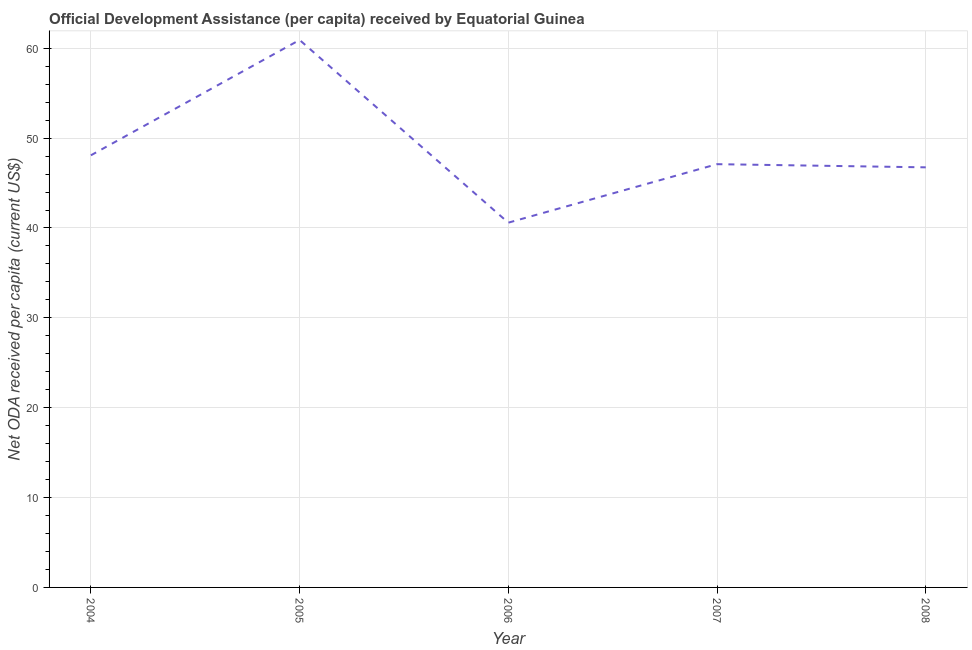What is the net oda received per capita in 2007?
Your response must be concise. 47.1. Across all years, what is the maximum net oda received per capita?
Your response must be concise. 60.92. Across all years, what is the minimum net oda received per capita?
Your answer should be very brief. 40.59. In which year was the net oda received per capita maximum?
Provide a succinct answer. 2005. What is the sum of the net oda received per capita?
Keep it short and to the point. 243.45. What is the difference between the net oda received per capita in 2005 and 2006?
Keep it short and to the point. 20.33. What is the average net oda received per capita per year?
Your response must be concise. 48.69. What is the median net oda received per capita?
Offer a terse response. 47.1. In how many years, is the net oda received per capita greater than 30 US$?
Provide a short and direct response. 5. Do a majority of the years between 2004 and 2005 (inclusive) have net oda received per capita greater than 22 US$?
Ensure brevity in your answer.  Yes. What is the ratio of the net oda received per capita in 2005 to that in 2008?
Provide a short and direct response. 1.3. Is the difference between the net oda received per capita in 2007 and 2008 greater than the difference between any two years?
Your answer should be very brief. No. What is the difference between the highest and the second highest net oda received per capita?
Offer a very short reply. 12.84. What is the difference between the highest and the lowest net oda received per capita?
Ensure brevity in your answer.  20.33. In how many years, is the net oda received per capita greater than the average net oda received per capita taken over all years?
Make the answer very short. 1. What is the difference between two consecutive major ticks on the Y-axis?
Your answer should be compact. 10. Does the graph contain any zero values?
Your answer should be very brief. No. Does the graph contain grids?
Offer a very short reply. Yes. What is the title of the graph?
Provide a succinct answer. Official Development Assistance (per capita) received by Equatorial Guinea. What is the label or title of the X-axis?
Your answer should be compact. Year. What is the label or title of the Y-axis?
Ensure brevity in your answer.  Net ODA received per capita (current US$). What is the Net ODA received per capita (current US$) in 2004?
Offer a terse response. 48.09. What is the Net ODA received per capita (current US$) of 2005?
Make the answer very short. 60.92. What is the Net ODA received per capita (current US$) of 2006?
Your answer should be very brief. 40.59. What is the Net ODA received per capita (current US$) in 2007?
Your answer should be compact. 47.1. What is the Net ODA received per capita (current US$) of 2008?
Your answer should be very brief. 46.75. What is the difference between the Net ODA received per capita (current US$) in 2004 and 2005?
Your answer should be compact. -12.84. What is the difference between the Net ODA received per capita (current US$) in 2004 and 2006?
Give a very brief answer. 7.5. What is the difference between the Net ODA received per capita (current US$) in 2004 and 2007?
Your response must be concise. 0.98. What is the difference between the Net ODA received per capita (current US$) in 2004 and 2008?
Make the answer very short. 1.34. What is the difference between the Net ODA received per capita (current US$) in 2005 and 2006?
Provide a succinct answer. 20.33. What is the difference between the Net ODA received per capita (current US$) in 2005 and 2007?
Offer a terse response. 13.82. What is the difference between the Net ODA received per capita (current US$) in 2005 and 2008?
Offer a terse response. 14.17. What is the difference between the Net ODA received per capita (current US$) in 2006 and 2007?
Keep it short and to the point. -6.51. What is the difference between the Net ODA received per capita (current US$) in 2006 and 2008?
Your answer should be compact. -6.16. What is the difference between the Net ODA received per capita (current US$) in 2007 and 2008?
Your answer should be very brief. 0.35. What is the ratio of the Net ODA received per capita (current US$) in 2004 to that in 2005?
Provide a short and direct response. 0.79. What is the ratio of the Net ODA received per capita (current US$) in 2004 to that in 2006?
Make the answer very short. 1.19. What is the ratio of the Net ODA received per capita (current US$) in 2005 to that in 2006?
Your response must be concise. 1.5. What is the ratio of the Net ODA received per capita (current US$) in 2005 to that in 2007?
Give a very brief answer. 1.29. What is the ratio of the Net ODA received per capita (current US$) in 2005 to that in 2008?
Your answer should be compact. 1.3. What is the ratio of the Net ODA received per capita (current US$) in 2006 to that in 2007?
Your answer should be very brief. 0.86. What is the ratio of the Net ODA received per capita (current US$) in 2006 to that in 2008?
Your response must be concise. 0.87. 